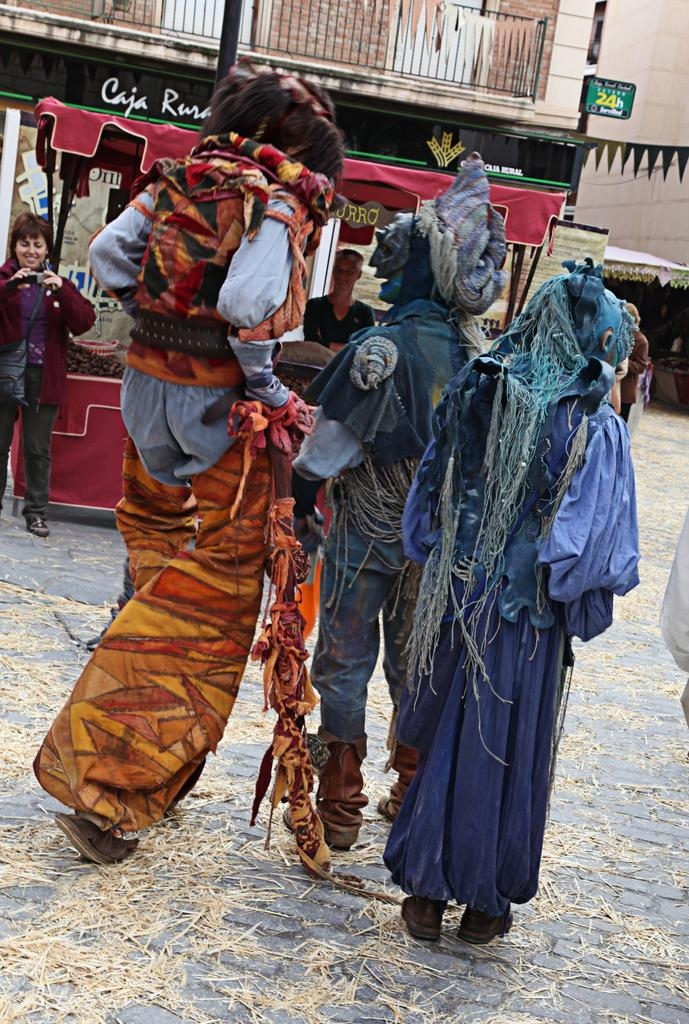What is happening in the image? There are three persons walking in the image. How are the three persons dressed? The persons are wearing different kinds of dresses. What is the woman on the left side of the image doing? The woman is standing on the left side of the image and taking photographs of the three persons. What type of bushes can be seen in the background of the image? There are no bushes visible in the image. What game is the grandfather playing with the three persons in the image? There is no grandfather or game present in the image. 